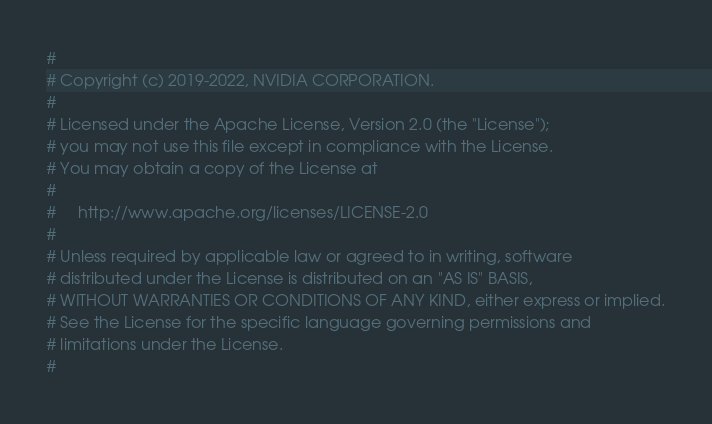Convert code to text. <code><loc_0><loc_0><loc_500><loc_500><_Cython_>#
# Copyright (c) 2019-2022, NVIDIA CORPORATION.
#
# Licensed under the Apache License, Version 2.0 (the "License");
# you may not use this file except in compliance with the License.
# You may obtain a copy of the License at
#
#     http://www.apache.org/licenses/LICENSE-2.0
#
# Unless required by applicable law or agreed to in writing, software
# distributed under the License is distributed on an "AS IS" BASIS,
# WITHOUT WARRANTIES OR CONDITIONS OF ANY KIND, either express or implied.
# See the License for the specific language governing permissions and
# limitations under the License.
#
</code> 